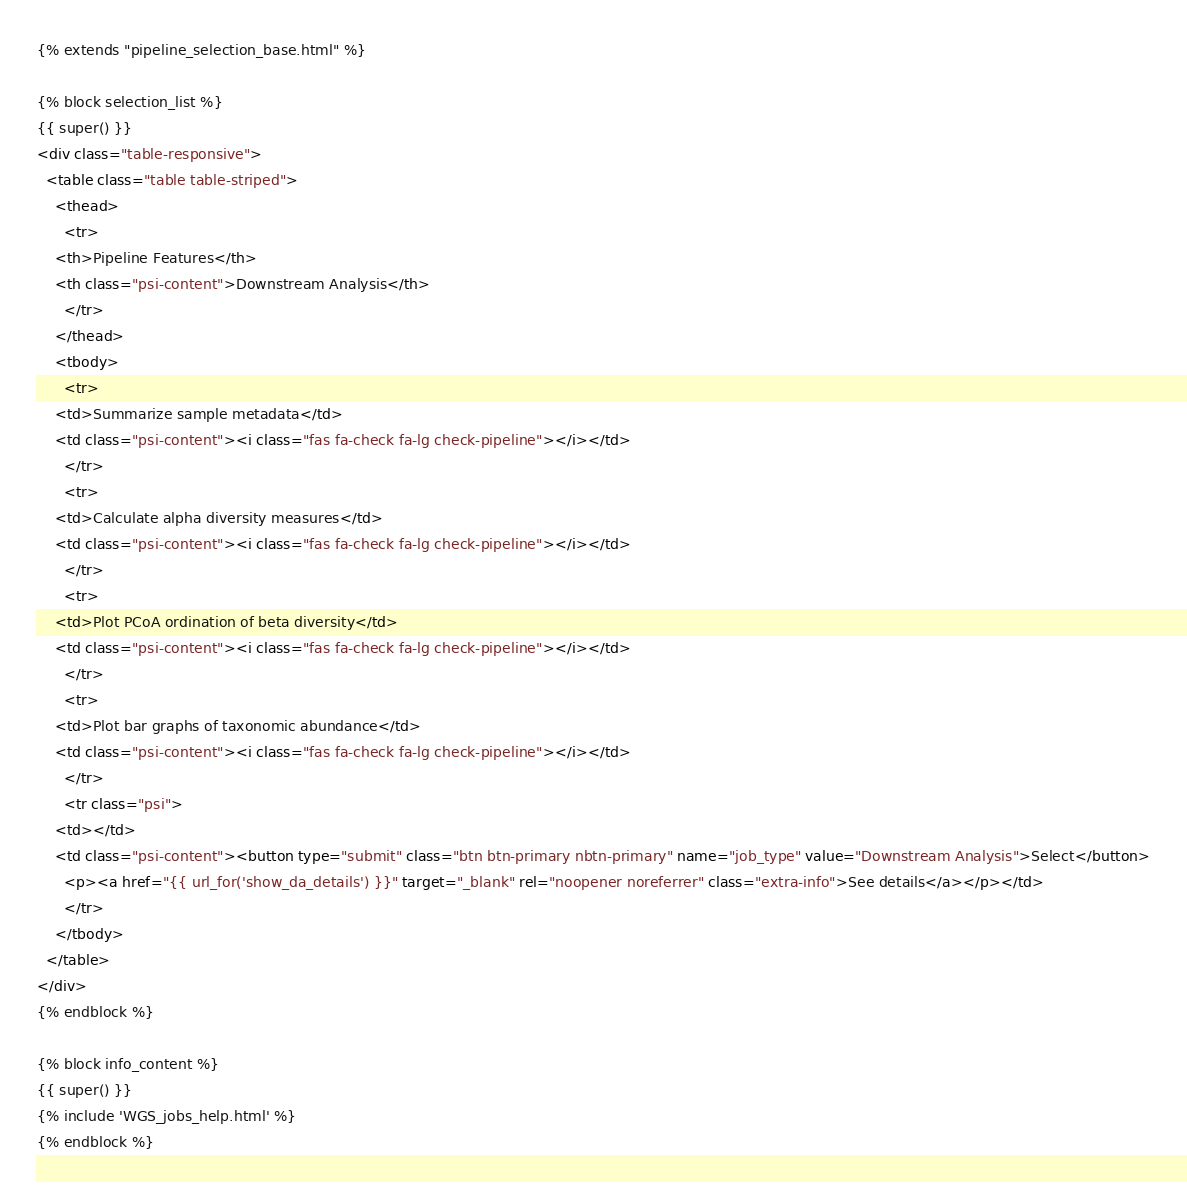Convert code to text. <code><loc_0><loc_0><loc_500><loc_500><_HTML_>{% extends "pipeline_selection_base.html" %}

{% block selection_list %}
{{ super() }}
<div class="table-responsive">
  <table class="table table-striped">
    <thead>
      <tr>
	<th>Pipeline Features</th>
	<th class="psi-content">Downstream Analysis</th>
      </tr>
    </thead>
    <tbody>
      <tr>
	<td>Summarize sample metadata</td>
	<td class="psi-content"><i class="fas fa-check fa-lg check-pipeline"></i></td>
      </tr>
      <tr>
	<td>Calculate alpha diversity measures</td>
	<td class="psi-content"><i class="fas fa-check fa-lg check-pipeline"></i></td>
      </tr>
      <tr>
	<td>Plot PCoA ordination of beta diversity</td>
	<td class="psi-content"><i class="fas fa-check fa-lg check-pipeline"></i></td>
      </tr>
      <tr>
	<td>Plot bar graphs of taxonomic abundance</td>
	<td class="psi-content"><i class="fas fa-check fa-lg check-pipeline"></i></td>
      </tr>
      <tr class="psi">
	<td></td>
	<td class="psi-content"><button type="submit" class="btn btn-primary nbtn-primary" name="job_type" value="Downstream Analysis">Select</button>
	  <p><a href="{{ url_for('show_da_details') }}" target="_blank" rel="noopener noreferrer" class="extra-info">See details</a></p></td>
      </tr>
    </tbody>
  </table>
</div>
{% endblock %}

{% block info_content %}
{{ super() }}
{% include 'WGS_jobs_help.html' %}
{% endblock %}
</code> 